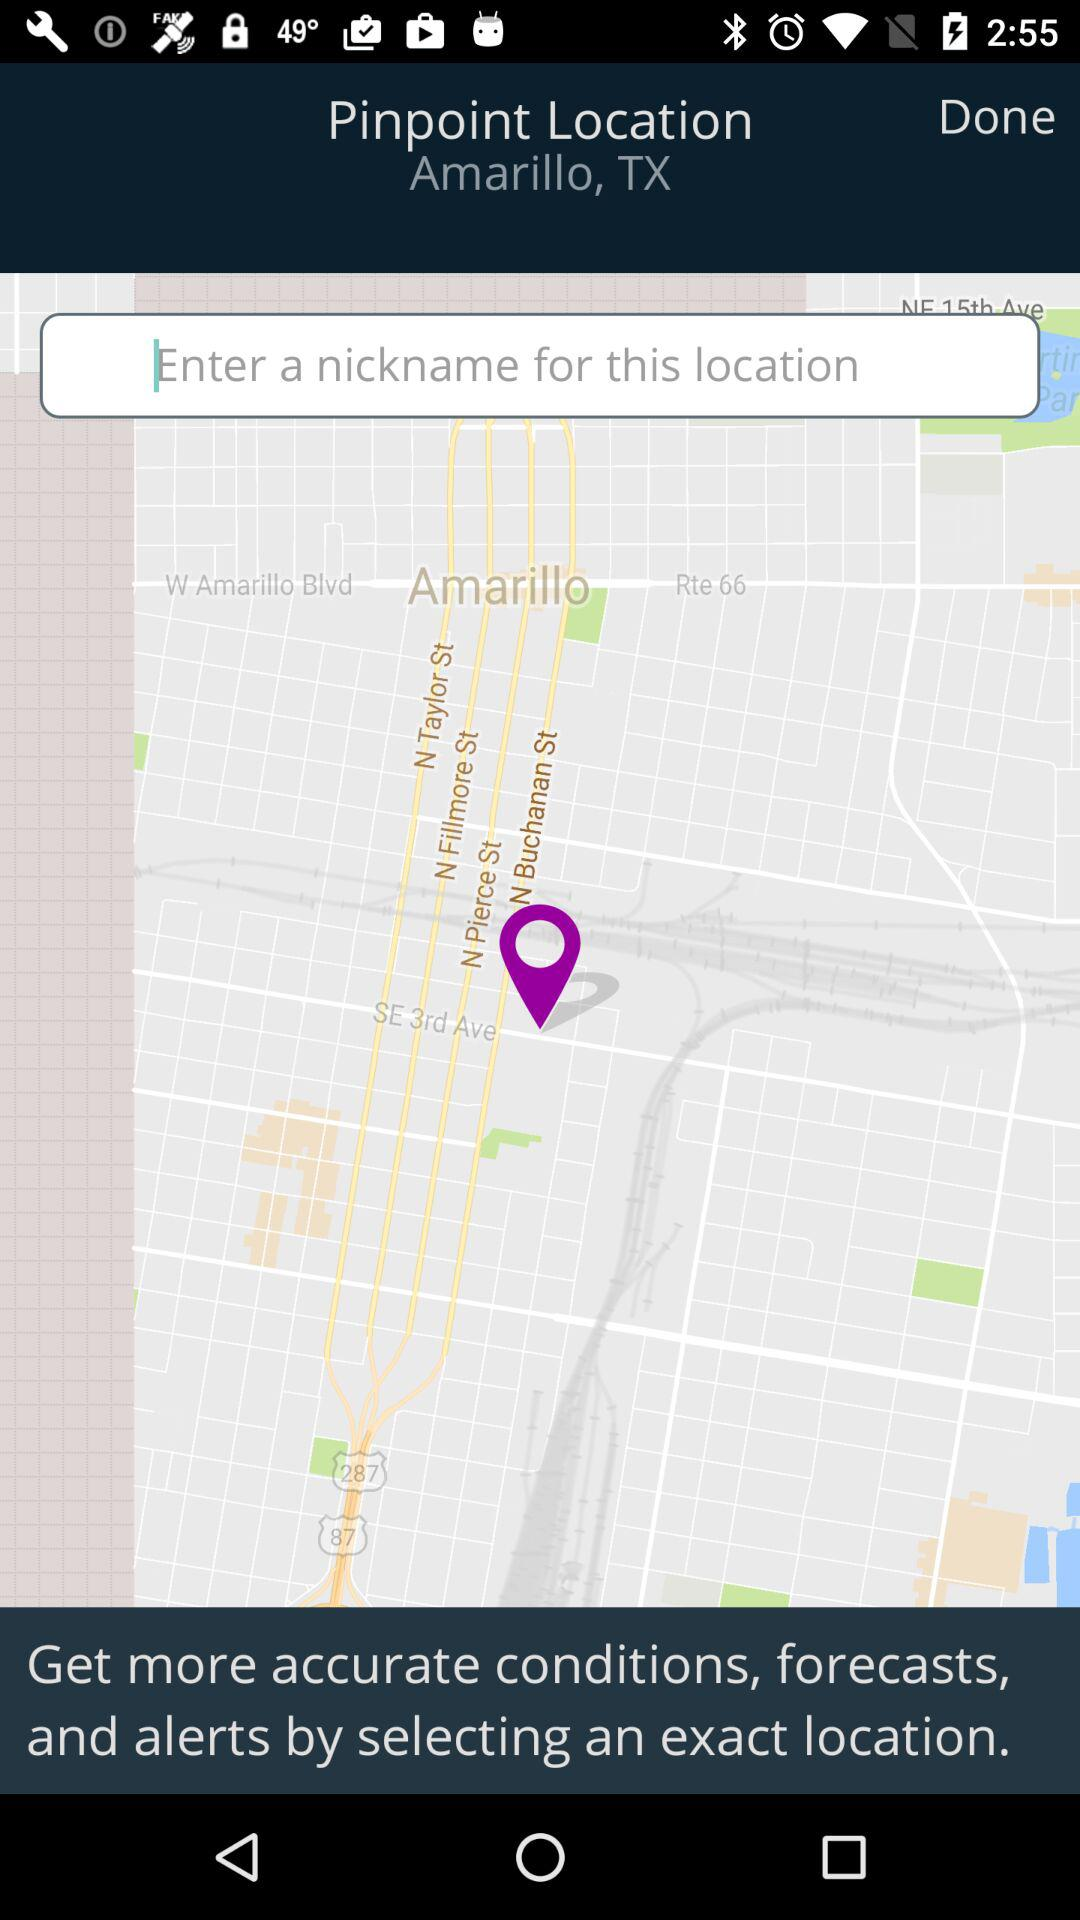What's the pinpoint location? The pinpoint location is Amarillo, TX. 